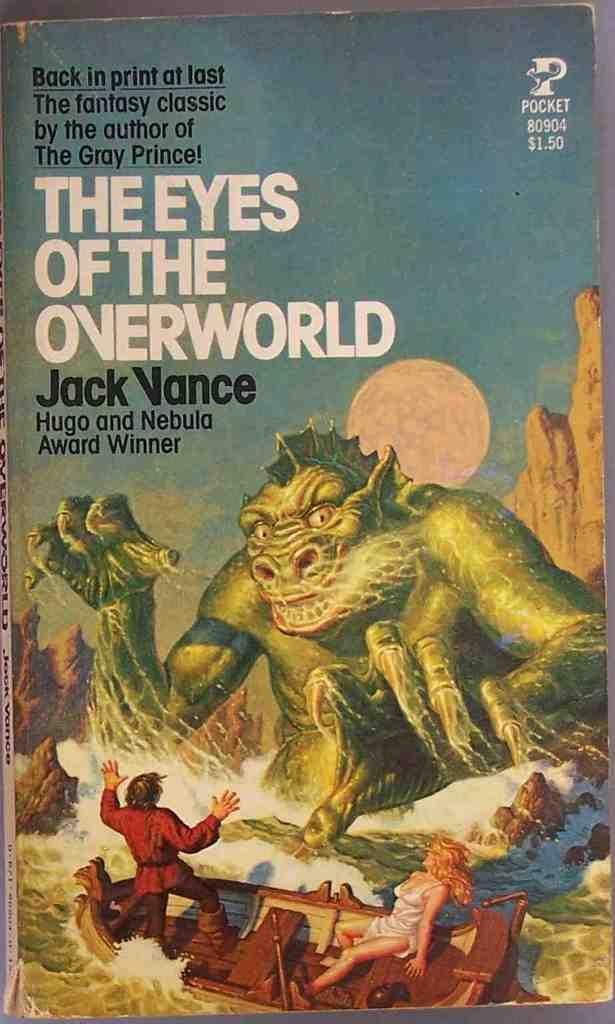<image>
Summarize the visual content of the image. monster overturning small boat of people on front of the eyes of the overworld paperback book 